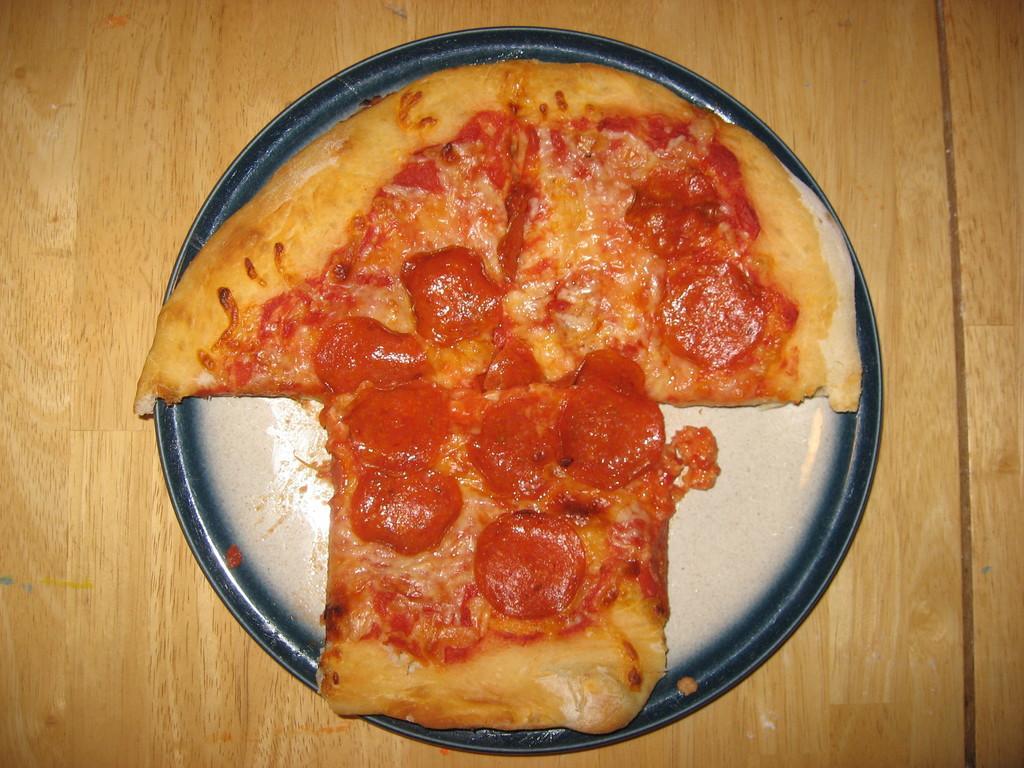Describe this image in one or two sentences. In the image we can see a plate, in the plate there is a food item and this is a wooden surface. 